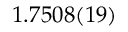Convert formula to latex. <formula><loc_0><loc_0><loc_500><loc_500>1 . 7 5 0 8 ( 1 9 )</formula> 